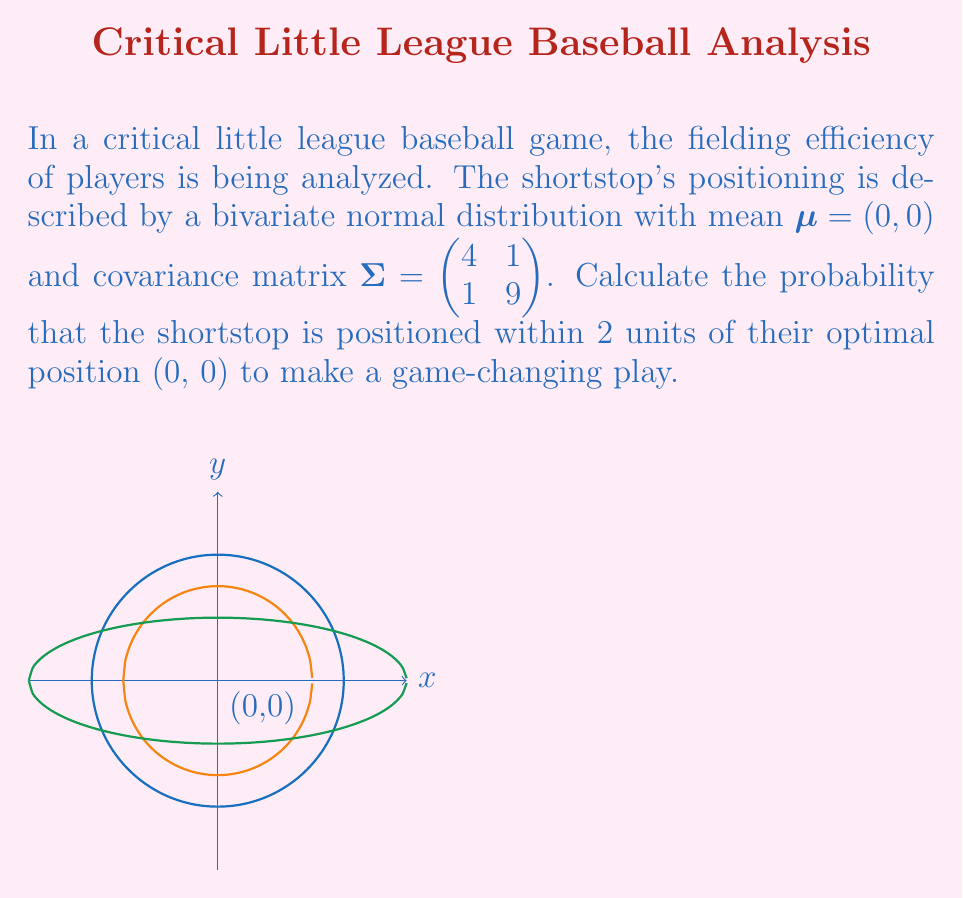Provide a solution to this math problem. Let's approach this step-by-step:

1) The probability density function of a bivariate normal distribution is given by:

   $$f(x,y) = \frac{1}{2\pi|\Sigma|^{1/2}} \exp\left(-\frac{1}{2}(x-\mu)^T\Sigma^{-1}(x-\mu)\right)$$

2) We're given $\mu = (0,0)$ and $\Sigma = \begin{pmatrix} 4 & 1 \\ 1 & 9 \end{pmatrix}$

3) To find the probability within 2 units, we need to integrate this function over a circle with radius 2. However, this is computationally complex.

4) Instead, we can use the Mahalanobis distance. For a bivariate normal distribution, the squared Mahalanobis distance follows a chi-square distribution with 2 degrees of freedom.

5) The squared Mahalanobis distance is given by:

   $$D^2 = (x-\mu)^T\Sigma^{-1}(x-\mu)$$

6) For points on the circle boundary, $x^2 + y^2 = 2^2 = 4$

7) The inverse of $\Sigma$ is:

   $$\Sigma^{-1} = \frac{1}{35}\begin{pmatrix} 9 & -1 \\ -1 & 4 \end{pmatrix}$$

8) Substituting into the Mahalanobis distance formula:

   $$D^2 = \frac{1}{35}(9x^2 - 2xy + 4y^2) \leq \frac{1}{35}(9x^2 + 4y^2) \leq \frac{1}{35}(9 \cdot 4) = \frac{36}{35}$$

9) The probability is then equal to the cumulative distribution function of the chi-square distribution with 2 degrees of freedom at $\frac{36}{35}$:

   $$P(D^2 \leq \frac{36}{35}) = 1 - e^{-\frac{36}{70}} \approx 0.4012$$
Answer: $0.4012$ or $40.12\%$ 